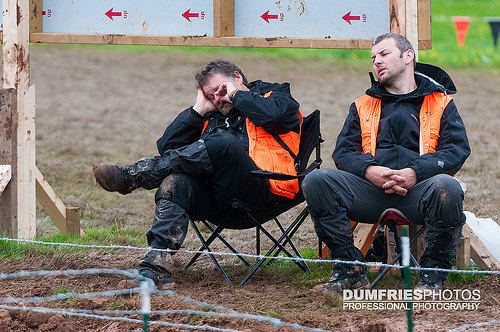<image>
Is the man on the chair? No. The man is not positioned on the chair. They may be near each other, but the man is not supported by or resting on top of the chair. 